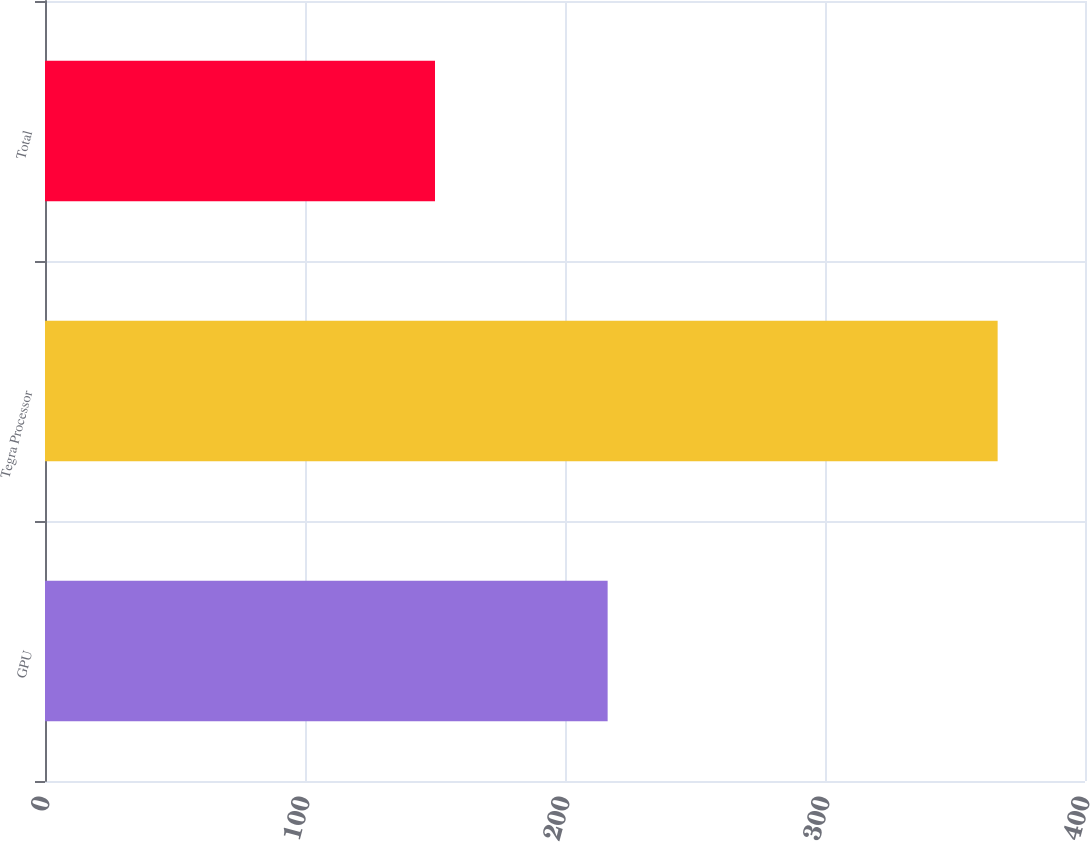Convert chart. <chart><loc_0><loc_0><loc_500><loc_500><bar_chart><fcel>GPU<fcel>Tegra Processor<fcel>Total<nl><fcel>216.4<fcel>366.4<fcel>150<nl></chart> 